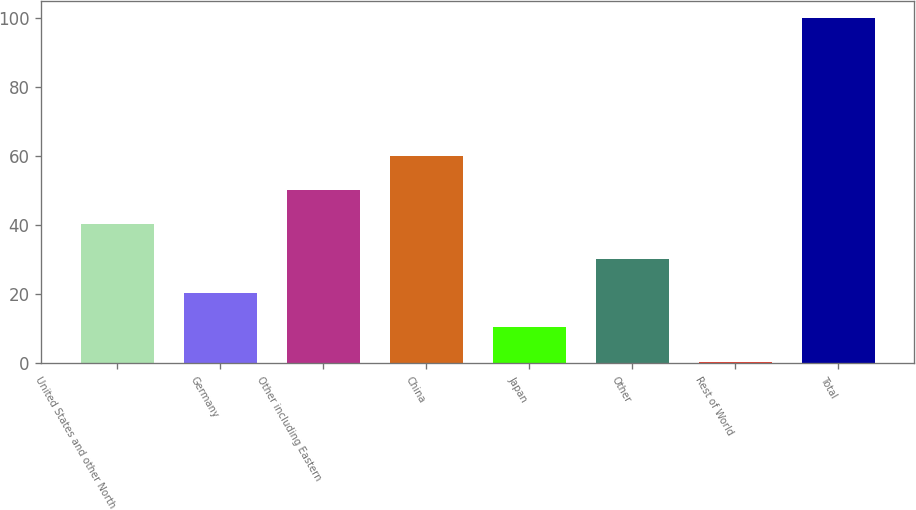Convert chart to OTSL. <chart><loc_0><loc_0><loc_500><loc_500><bar_chart><fcel>United States and other North<fcel>Germany<fcel>Other including Eastern<fcel>China<fcel>Japan<fcel>Other<fcel>Rest of World<fcel>Total<nl><fcel>40.18<fcel>20.24<fcel>50.15<fcel>60.12<fcel>10.27<fcel>30.21<fcel>0.3<fcel>100<nl></chart> 